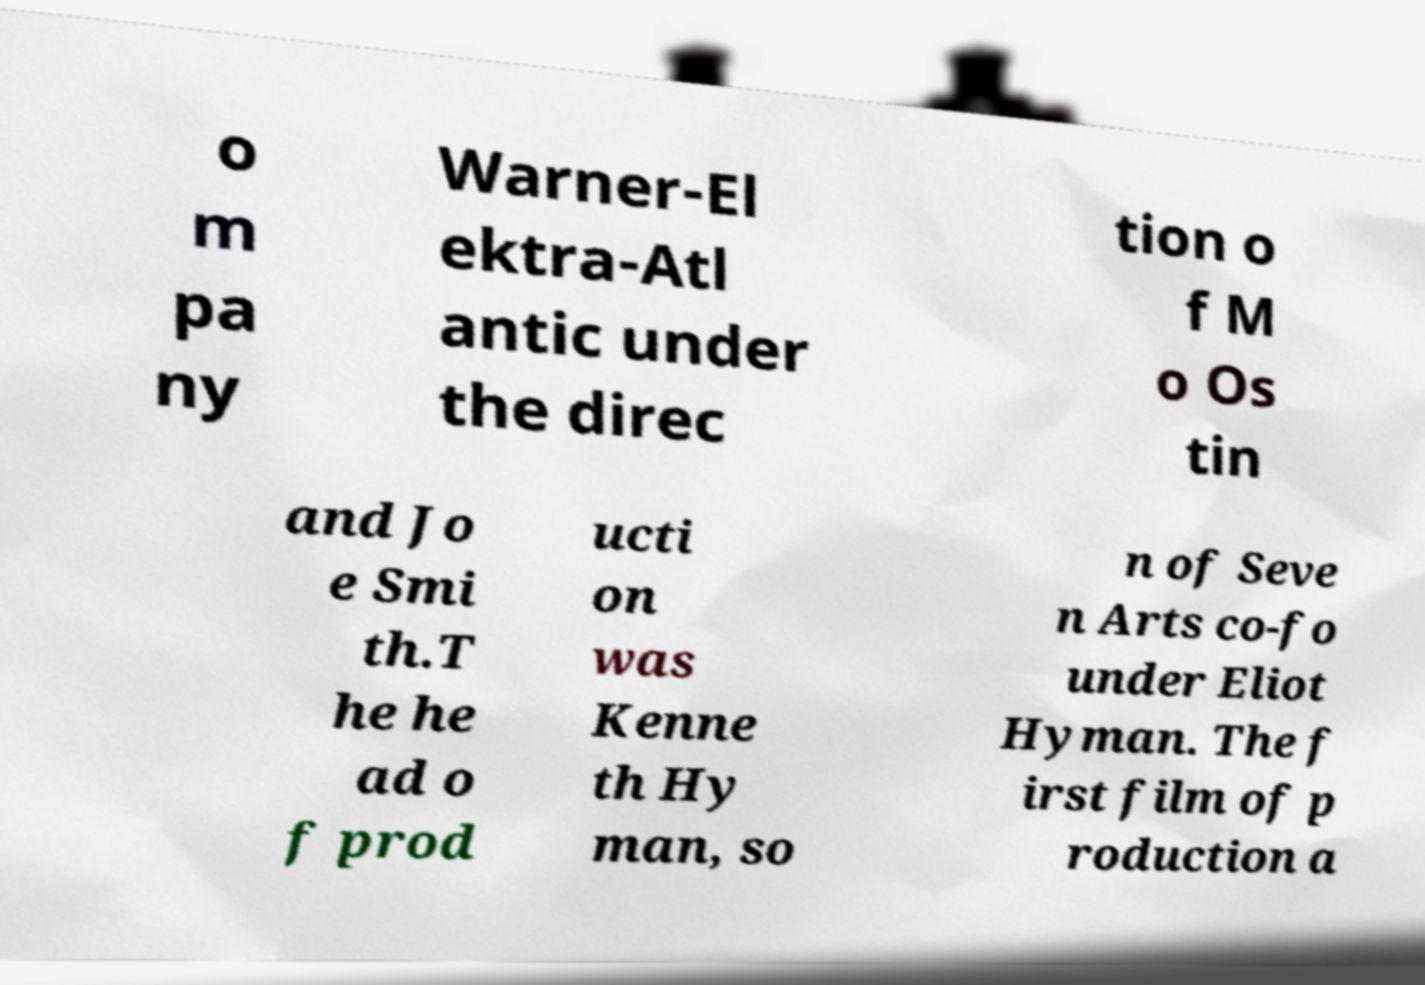There's text embedded in this image that I need extracted. Can you transcribe it verbatim? o m pa ny Warner-El ektra-Atl antic under the direc tion o f M o Os tin and Jo e Smi th.T he he ad o f prod ucti on was Kenne th Hy man, so n of Seve n Arts co-fo under Eliot Hyman. The f irst film of p roduction a 